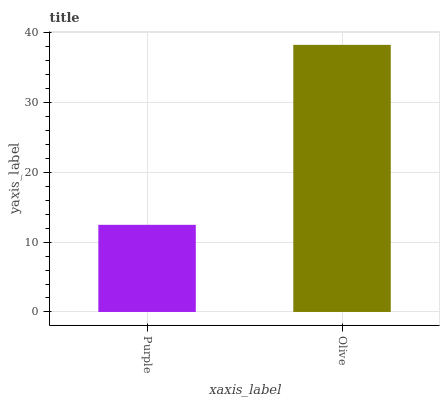Is Purple the minimum?
Answer yes or no. Yes. Is Olive the maximum?
Answer yes or no. Yes. Is Olive the minimum?
Answer yes or no. No. Is Olive greater than Purple?
Answer yes or no. Yes. Is Purple less than Olive?
Answer yes or no. Yes. Is Purple greater than Olive?
Answer yes or no. No. Is Olive less than Purple?
Answer yes or no. No. Is Olive the high median?
Answer yes or no. Yes. Is Purple the low median?
Answer yes or no. Yes. Is Purple the high median?
Answer yes or no. No. Is Olive the low median?
Answer yes or no. No. 